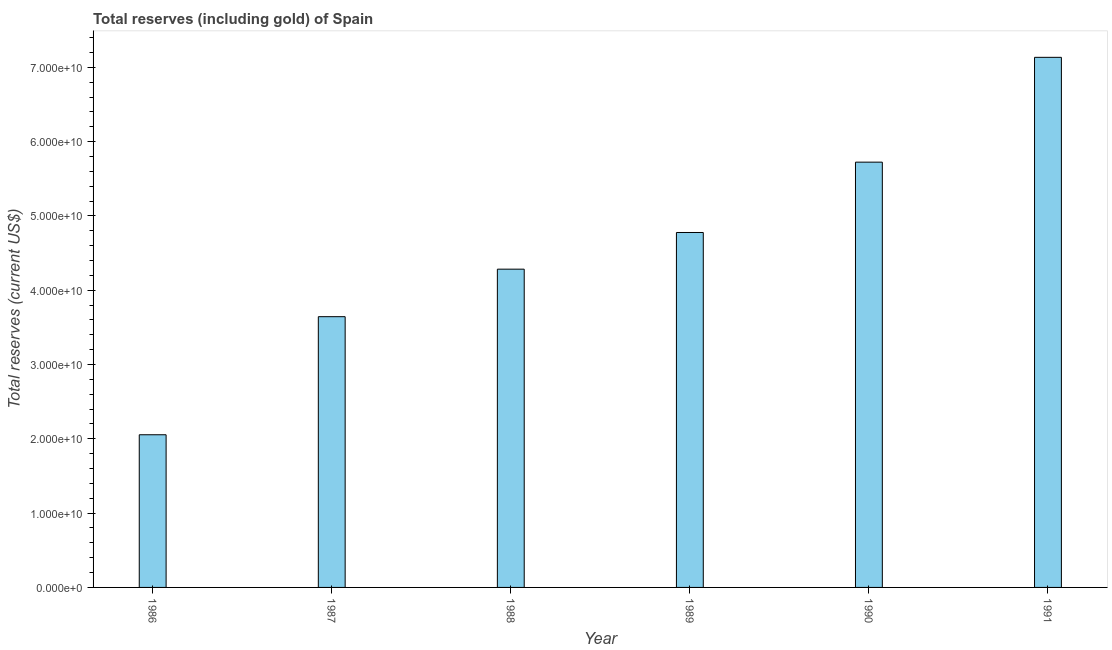Does the graph contain any zero values?
Offer a very short reply. No. Does the graph contain grids?
Offer a very short reply. No. What is the title of the graph?
Offer a terse response. Total reserves (including gold) of Spain. What is the label or title of the X-axis?
Your response must be concise. Year. What is the label or title of the Y-axis?
Provide a short and direct response. Total reserves (current US$). What is the total reserves (including gold) in 1989?
Offer a terse response. 4.78e+1. Across all years, what is the maximum total reserves (including gold)?
Your answer should be compact. 7.13e+1. Across all years, what is the minimum total reserves (including gold)?
Provide a short and direct response. 2.05e+1. In which year was the total reserves (including gold) minimum?
Provide a succinct answer. 1986. What is the sum of the total reserves (including gold)?
Your response must be concise. 2.76e+11. What is the difference between the total reserves (including gold) in 1989 and 1991?
Your response must be concise. -2.36e+1. What is the average total reserves (including gold) per year?
Keep it short and to the point. 4.60e+1. What is the median total reserves (including gold)?
Make the answer very short. 4.53e+1. In how many years, is the total reserves (including gold) greater than 22000000000 US$?
Your answer should be very brief. 5. Do a majority of the years between 1987 and 1988 (inclusive) have total reserves (including gold) greater than 2000000000 US$?
Offer a very short reply. Yes. What is the ratio of the total reserves (including gold) in 1989 to that in 1991?
Give a very brief answer. 0.67. Is the total reserves (including gold) in 1990 less than that in 1991?
Your answer should be very brief. Yes. What is the difference between the highest and the second highest total reserves (including gold)?
Provide a succinct answer. 1.41e+1. What is the difference between the highest and the lowest total reserves (including gold)?
Provide a short and direct response. 5.08e+1. How many years are there in the graph?
Your answer should be compact. 6. What is the Total reserves (current US$) in 1986?
Your answer should be very brief. 2.05e+1. What is the Total reserves (current US$) in 1987?
Offer a very short reply. 3.64e+1. What is the Total reserves (current US$) in 1988?
Your response must be concise. 4.28e+1. What is the Total reserves (current US$) in 1989?
Make the answer very short. 4.78e+1. What is the Total reserves (current US$) of 1990?
Provide a short and direct response. 5.72e+1. What is the Total reserves (current US$) in 1991?
Offer a terse response. 7.13e+1. What is the difference between the Total reserves (current US$) in 1986 and 1987?
Ensure brevity in your answer.  -1.59e+1. What is the difference between the Total reserves (current US$) in 1986 and 1988?
Give a very brief answer. -2.23e+1. What is the difference between the Total reserves (current US$) in 1986 and 1989?
Provide a succinct answer. -2.72e+1. What is the difference between the Total reserves (current US$) in 1986 and 1990?
Keep it short and to the point. -3.67e+1. What is the difference between the Total reserves (current US$) in 1986 and 1991?
Offer a terse response. -5.08e+1. What is the difference between the Total reserves (current US$) in 1987 and 1988?
Offer a terse response. -6.40e+09. What is the difference between the Total reserves (current US$) in 1987 and 1989?
Ensure brevity in your answer.  -1.13e+1. What is the difference between the Total reserves (current US$) in 1987 and 1990?
Your answer should be compact. -2.08e+1. What is the difference between the Total reserves (current US$) in 1987 and 1991?
Your response must be concise. -3.49e+1. What is the difference between the Total reserves (current US$) in 1988 and 1989?
Your answer should be very brief. -4.93e+09. What is the difference between the Total reserves (current US$) in 1988 and 1990?
Your answer should be compact. -1.44e+1. What is the difference between the Total reserves (current US$) in 1988 and 1991?
Offer a terse response. -2.85e+1. What is the difference between the Total reserves (current US$) in 1989 and 1990?
Your answer should be compact. -9.47e+09. What is the difference between the Total reserves (current US$) in 1989 and 1991?
Make the answer very short. -2.36e+1. What is the difference between the Total reserves (current US$) in 1990 and 1991?
Keep it short and to the point. -1.41e+1. What is the ratio of the Total reserves (current US$) in 1986 to that in 1987?
Offer a terse response. 0.56. What is the ratio of the Total reserves (current US$) in 1986 to that in 1988?
Your answer should be compact. 0.48. What is the ratio of the Total reserves (current US$) in 1986 to that in 1989?
Provide a short and direct response. 0.43. What is the ratio of the Total reserves (current US$) in 1986 to that in 1990?
Offer a terse response. 0.36. What is the ratio of the Total reserves (current US$) in 1986 to that in 1991?
Make the answer very short. 0.29. What is the ratio of the Total reserves (current US$) in 1987 to that in 1988?
Your answer should be very brief. 0.85. What is the ratio of the Total reserves (current US$) in 1987 to that in 1989?
Offer a terse response. 0.76. What is the ratio of the Total reserves (current US$) in 1987 to that in 1990?
Your response must be concise. 0.64. What is the ratio of the Total reserves (current US$) in 1987 to that in 1991?
Give a very brief answer. 0.51. What is the ratio of the Total reserves (current US$) in 1988 to that in 1989?
Offer a very short reply. 0.9. What is the ratio of the Total reserves (current US$) in 1988 to that in 1990?
Your answer should be very brief. 0.75. What is the ratio of the Total reserves (current US$) in 1988 to that in 1991?
Give a very brief answer. 0.6. What is the ratio of the Total reserves (current US$) in 1989 to that in 1990?
Provide a short and direct response. 0.83. What is the ratio of the Total reserves (current US$) in 1989 to that in 1991?
Your answer should be very brief. 0.67. What is the ratio of the Total reserves (current US$) in 1990 to that in 1991?
Offer a terse response. 0.8. 